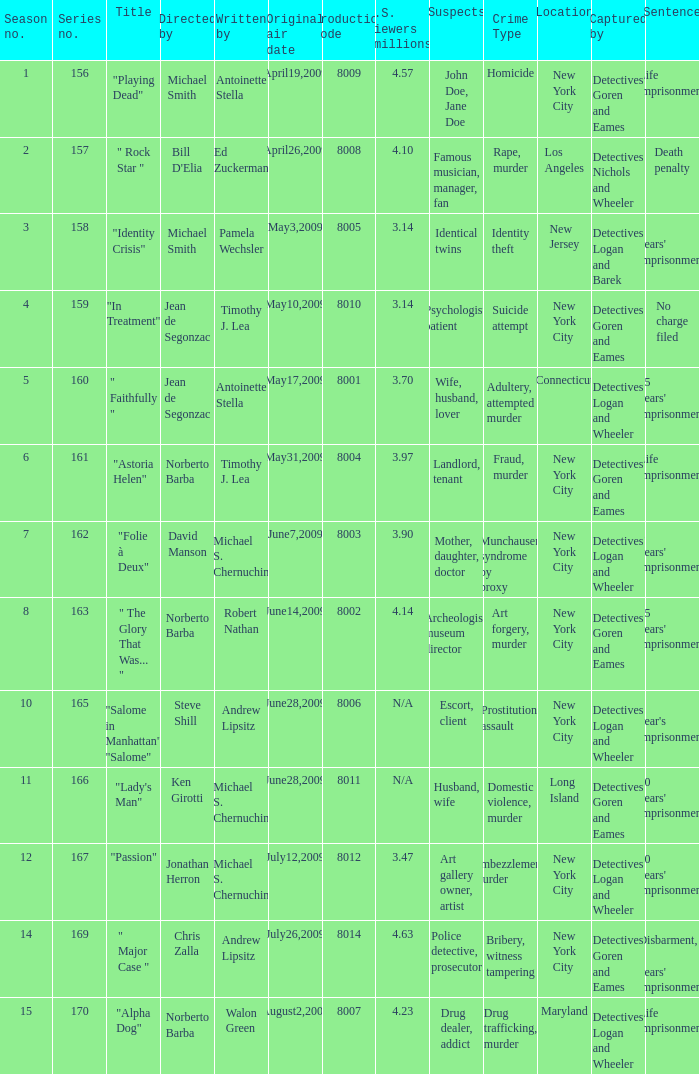Who are the writer of the series episode number 170? Walon Green. 